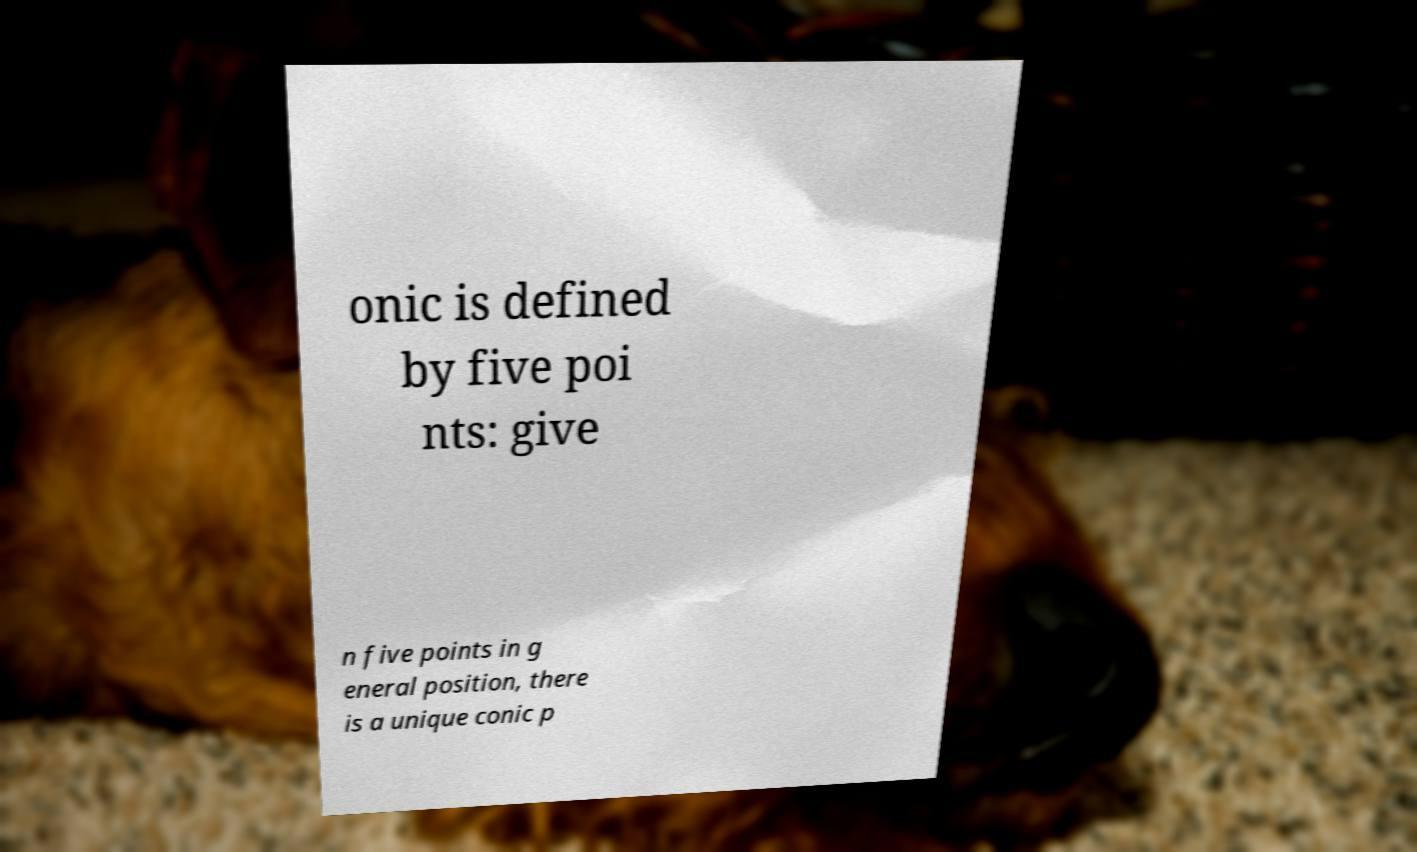Please read and relay the text visible in this image. What does it say? onic is defined by five poi nts: give n five points in g eneral position, there is a unique conic p 